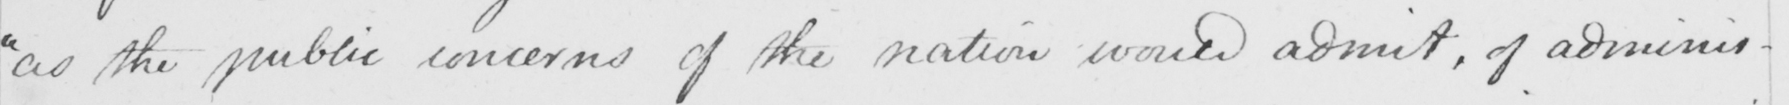What is written in this line of handwriting? " as the public concerns of the nation would admit , of adminis- 